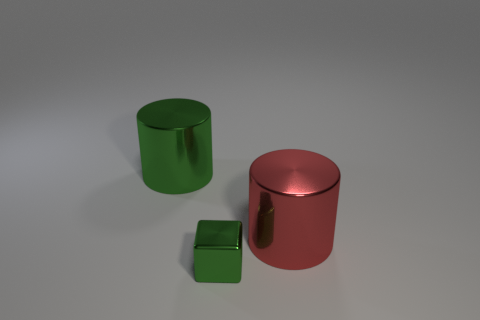Add 1 red matte things. How many objects exist? 4 Subtract all blocks. How many objects are left? 2 Subtract 0 gray cubes. How many objects are left? 3 Subtract all tiny blue blocks. Subtract all big red metallic objects. How many objects are left? 2 Add 2 small things. How many small things are left? 3 Add 1 large brown metallic cylinders. How many large brown metallic cylinders exist? 1 